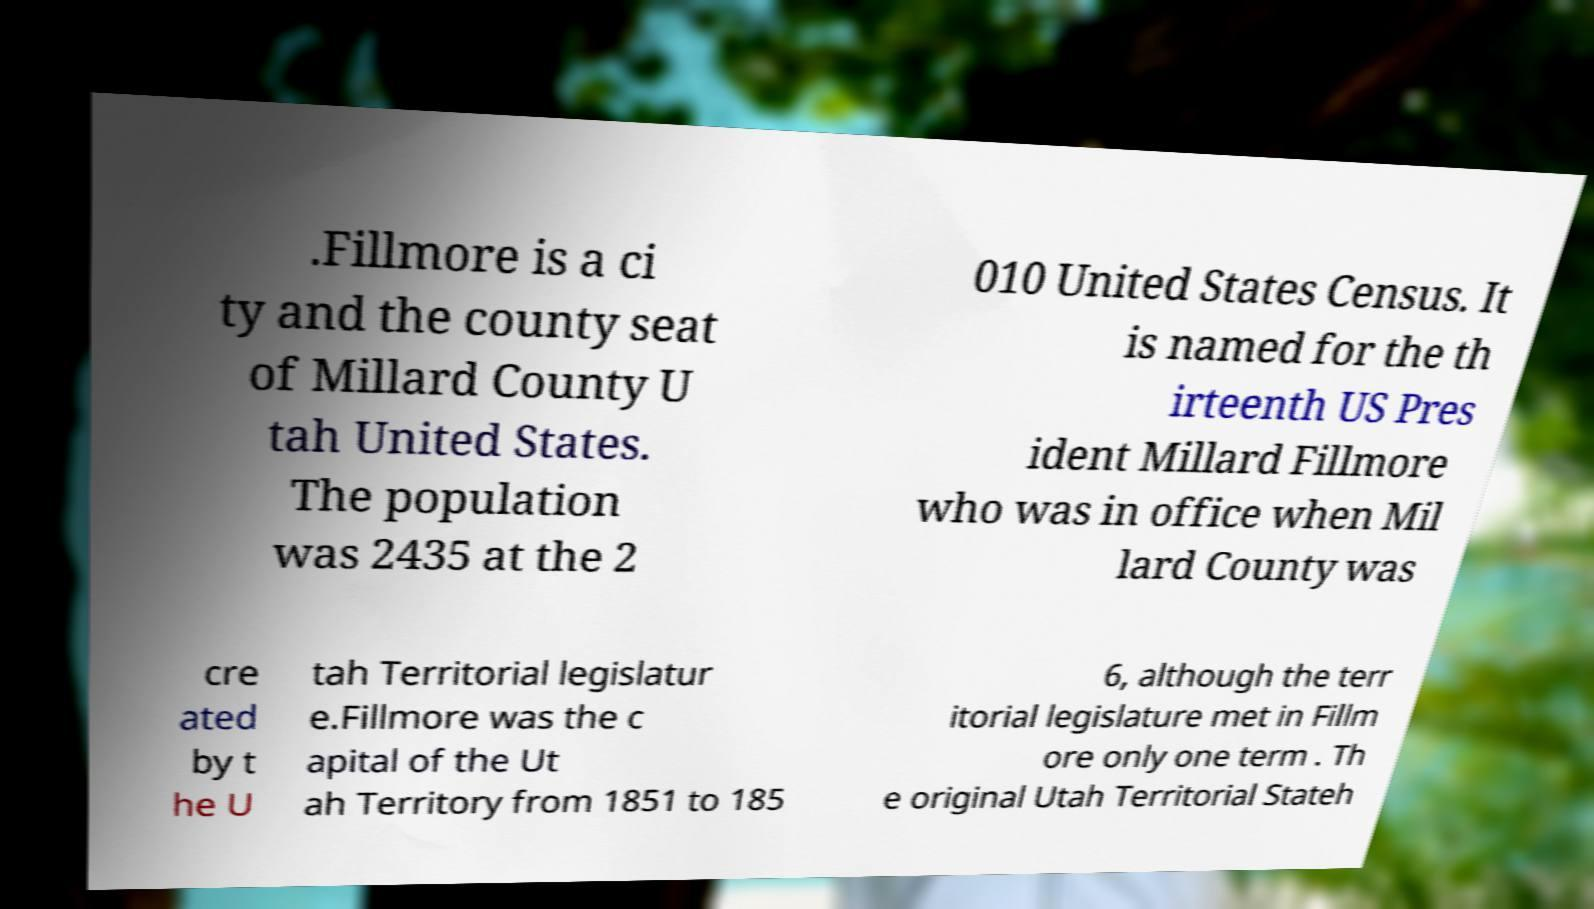Could you extract and type out the text from this image? .Fillmore is a ci ty and the county seat of Millard County U tah United States. The population was 2435 at the 2 010 United States Census. It is named for the th irteenth US Pres ident Millard Fillmore who was in office when Mil lard County was cre ated by t he U tah Territorial legislatur e.Fillmore was the c apital of the Ut ah Territory from 1851 to 185 6, although the terr itorial legislature met in Fillm ore only one term . Th e original Utah Territorial Stateh 